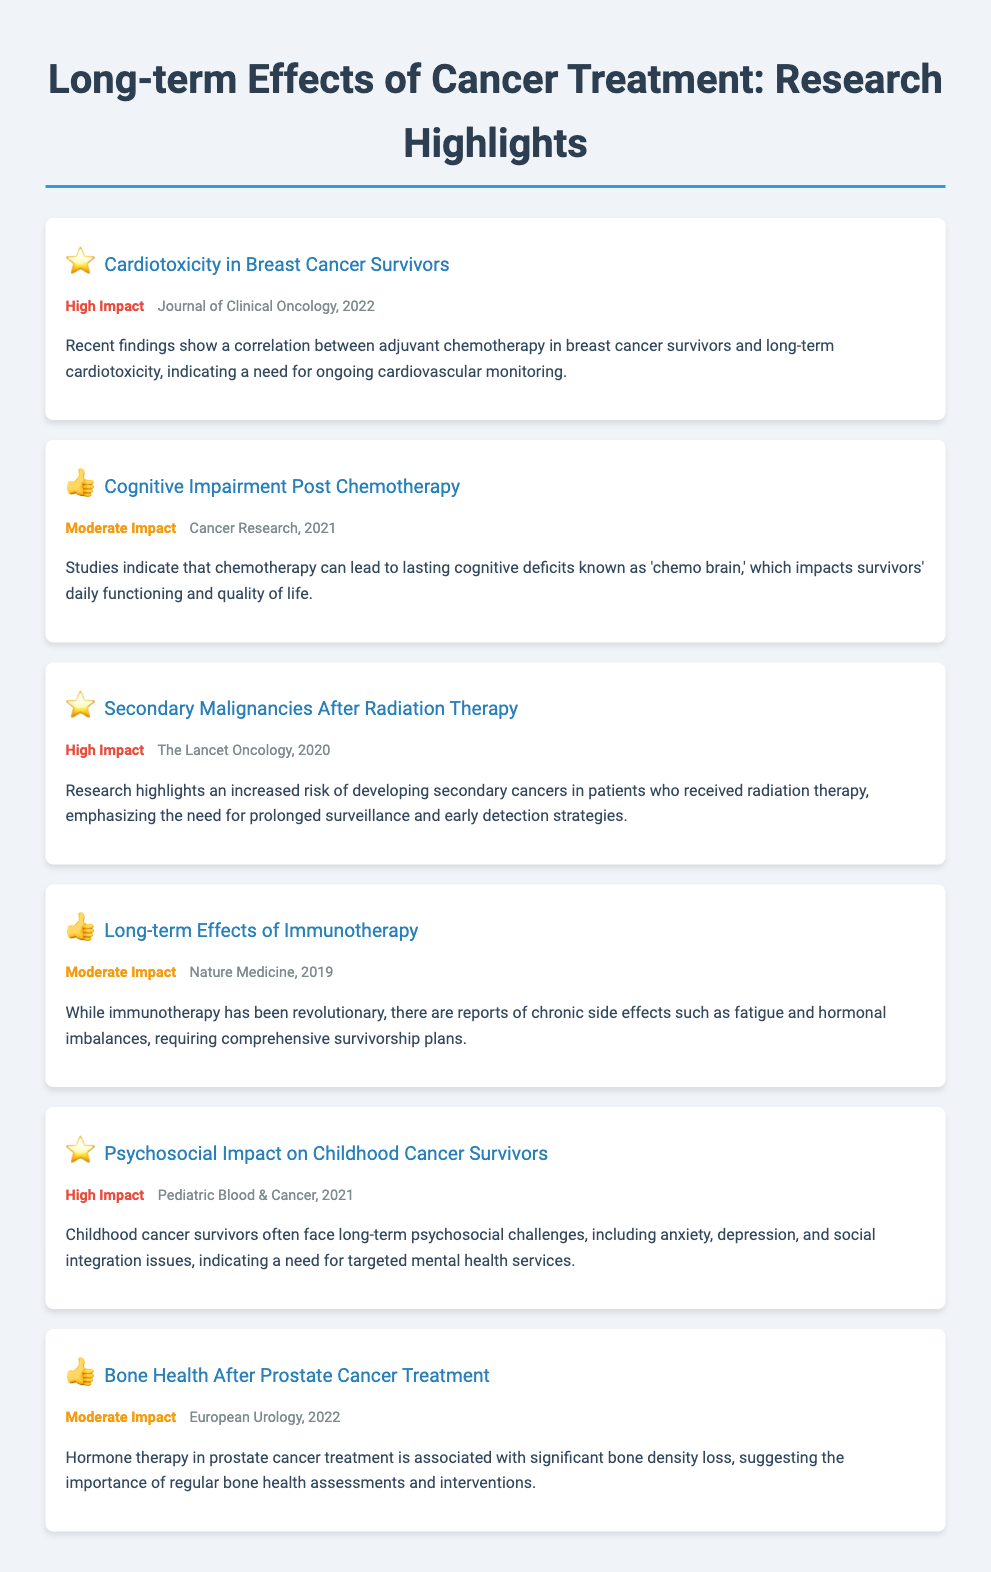what is the title of the document? The title of the document is specified in the header section and provides the focus of the research highlights.
Answer: Long-term Effects of Cancer Treatment: Research Highlights which journal published the study on cardiotoxicity? The reference for the cardiotoxicity study includes the name of the journal that published it.
Answer: Journal of Clinical Oncology how many studies were highlighted in the infographic? The number of studies can be determined by counting the research items listed in the document.
Answer: 6 what is indicated as a high impact finding? This question requires identifying a finding marked with a high impact label and mentions its relevance.
Answer: Cardiotoxicity in Breast Cancer Survivors what chronic side effects are reported from immunotherapy? This question prompts respondents to recall specific chronic side effects mentioned in the immunotherapy study.
Answer: Fatigue and hormonal imbalances which population is highlighted for psychosocial challenges? This question seeks to determine which specific group faces long-term challenges as outlined in the research findings.
Answer: Childhood cancer survivors when was the study on secondary malignancies published? The date of publication for the secondary malignancies study is confirmed in the meta information provided.
Answer: 2020 what type of health assessments are suggested for prostate cancer survivors? The answer will summarize the specific health assessments recommended within the context of prostate cancer treatment findings.
Answer: Bone health assessments 